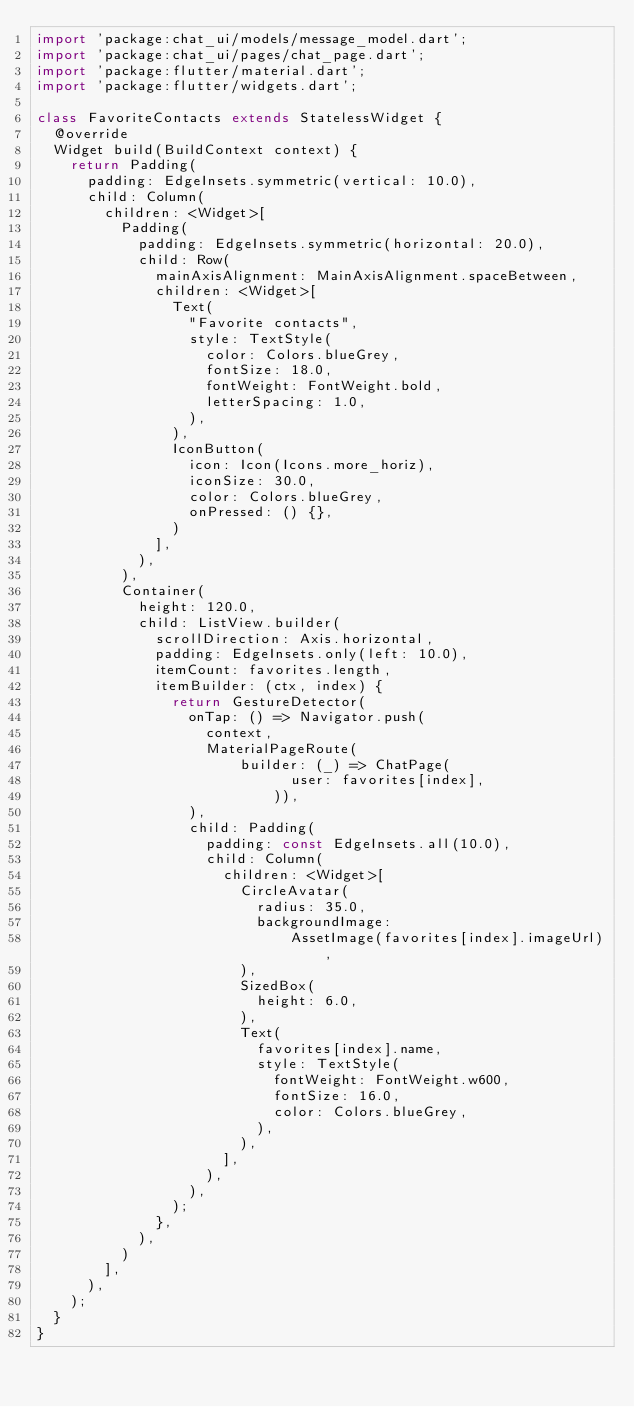<code> <loc_0><loc_0><loc_500><loc_500><_Dart_>import 'package:chat_ui/models/message_model.dart';
import 'package:chat_ui/pages/chat_page.dart';
import 'package:flutter/material.dart';
import 'package:flutter/widgets.dart';

class FavoriteContacts extends StatelessWidget {
  @override
  Widget build(BuildContext context) {
    return Padding(
      padding: EdgeInsets.symmetric(vertical: 10.0),
      child: Column(
        children: <Widget>[
          Padding(
            padding: EdgeInsets.symmetric(horizontal: 20.0),
            child: Row(
              mainAxisAlignment: MainAxisAlignment.spaceBetween,
              children: <Widget>[
                Text(
                  "Favorite contacts",
                  style: TextStyle(
                    color: Colors.blueGrey,
                    fontSize: 18.0,
                    fontWeight: FontWeight.bold,
                    letterSpacing: 1.0,
                  ),
                ),
                IconButton(
                  icon: Icon(Icons.more_horiz),
                  iconSize: 30.0,
                  color: Colors.blueGrey,
                  onPressed: () {},
                )
              ],
            ),
          ),
          Container(
            height: 120.0,
            child: ListView.builder(
              scrollDirection: Axis.horizontal,
              padding: EdgeInsets.only(left: 10.0),
              itemCount: favorites.length,
              itemBuilder: (ctx, index) {
                return GestureDetector(
                  onTap: () => Navigator.push(
                    context,
                    MaterialPageRoute(
                        builder: (_) => ChatPage(
                              user: favorites[index],
                            )),
                  ),
                  child: Padding(
                    padding: const EdgeInsets.all(10.0),
                    child: Column(
                      children: <Widget>[
                        CircleAvatar(
                          radius: 35.0,
                          backgroundImage:
                              AssetImage(favorites[index].imageUrl),
                        ),
                        SizedBox(
                          height: 6.0,
                        ),
                        Text(
                          favorites[index].name,
                          style: TextStyle(
                            fontWeight: FontWeight.w600,
                            fontSize: 16.0,
                            color: Colors.blueGrey,
                          ),
                        ),
                      ],
                    ),
                  ),
                );
              },
            ),
          )
        ],
      ),
    );
  }
}
</code> 